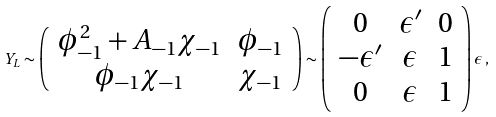Convert formula to latex. <formula><loc_0><loc_0><loc_500><loc_500>Y _ { L } \sim \left ( \begin{array} { c c } \phi ^ { 2 } _ { - 1 } + A _ { - 1 } \chi _ { - 1 } & \phi _ { - 1 } \\ \phi _ { - 1 } \chi _ { - 1 } & \chi _ { - 1 } \end{array} \right ) \sim \left ( \begin{array} { c c c } 0 & \epsilon ^ { \prime } & 0 \\ - \epsilon ^ { \prime } & \epsilon & 1 \\ 0 & \epsilon & 1 \end{array} \right ) \epsilon \, ,</formula> 